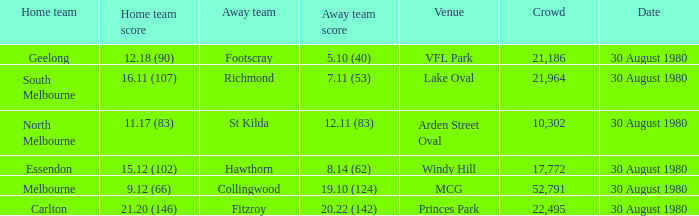What is the home team score at lake oval? 16.11 (107). 